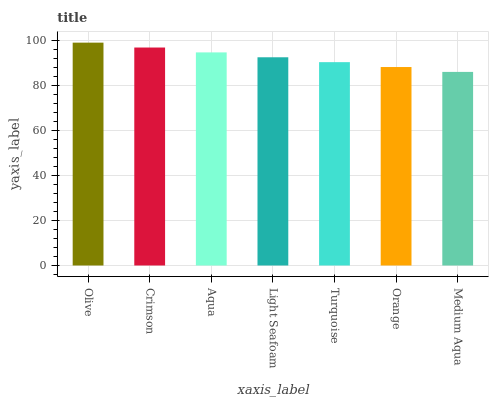Is Medium Aqua the minimum?
Answer yes or no. Yes. Is Olive the maximum?
Answer yes or no. Yes. Is Crimson the minimum?
Answer yes or no. No. Is Crimson the maximum?
Answer yes or no. No. Is Olive greater than Crimson?
Answer yes or no. Yes. Is Crimson less than Olive?
Answer yes or no. Yes. Is Crimson greater than Olive?
Answer yes or no. No. Is Olive less than Crimson?
Answer yes or no. No. Is Light Seafoam the high median?
Answer yes or no. Yes. Is Light Seafoam the low median?
Answer yes or no. Yes. Is Turquoise the high median?
Answer yes or no. No. Is Aqua the low median?
Answer yes or no. No. 